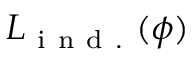<formula> <loc_0><loc_0><loc_500><loc_500>L _ { i n d . } ( \phi )</formula> 